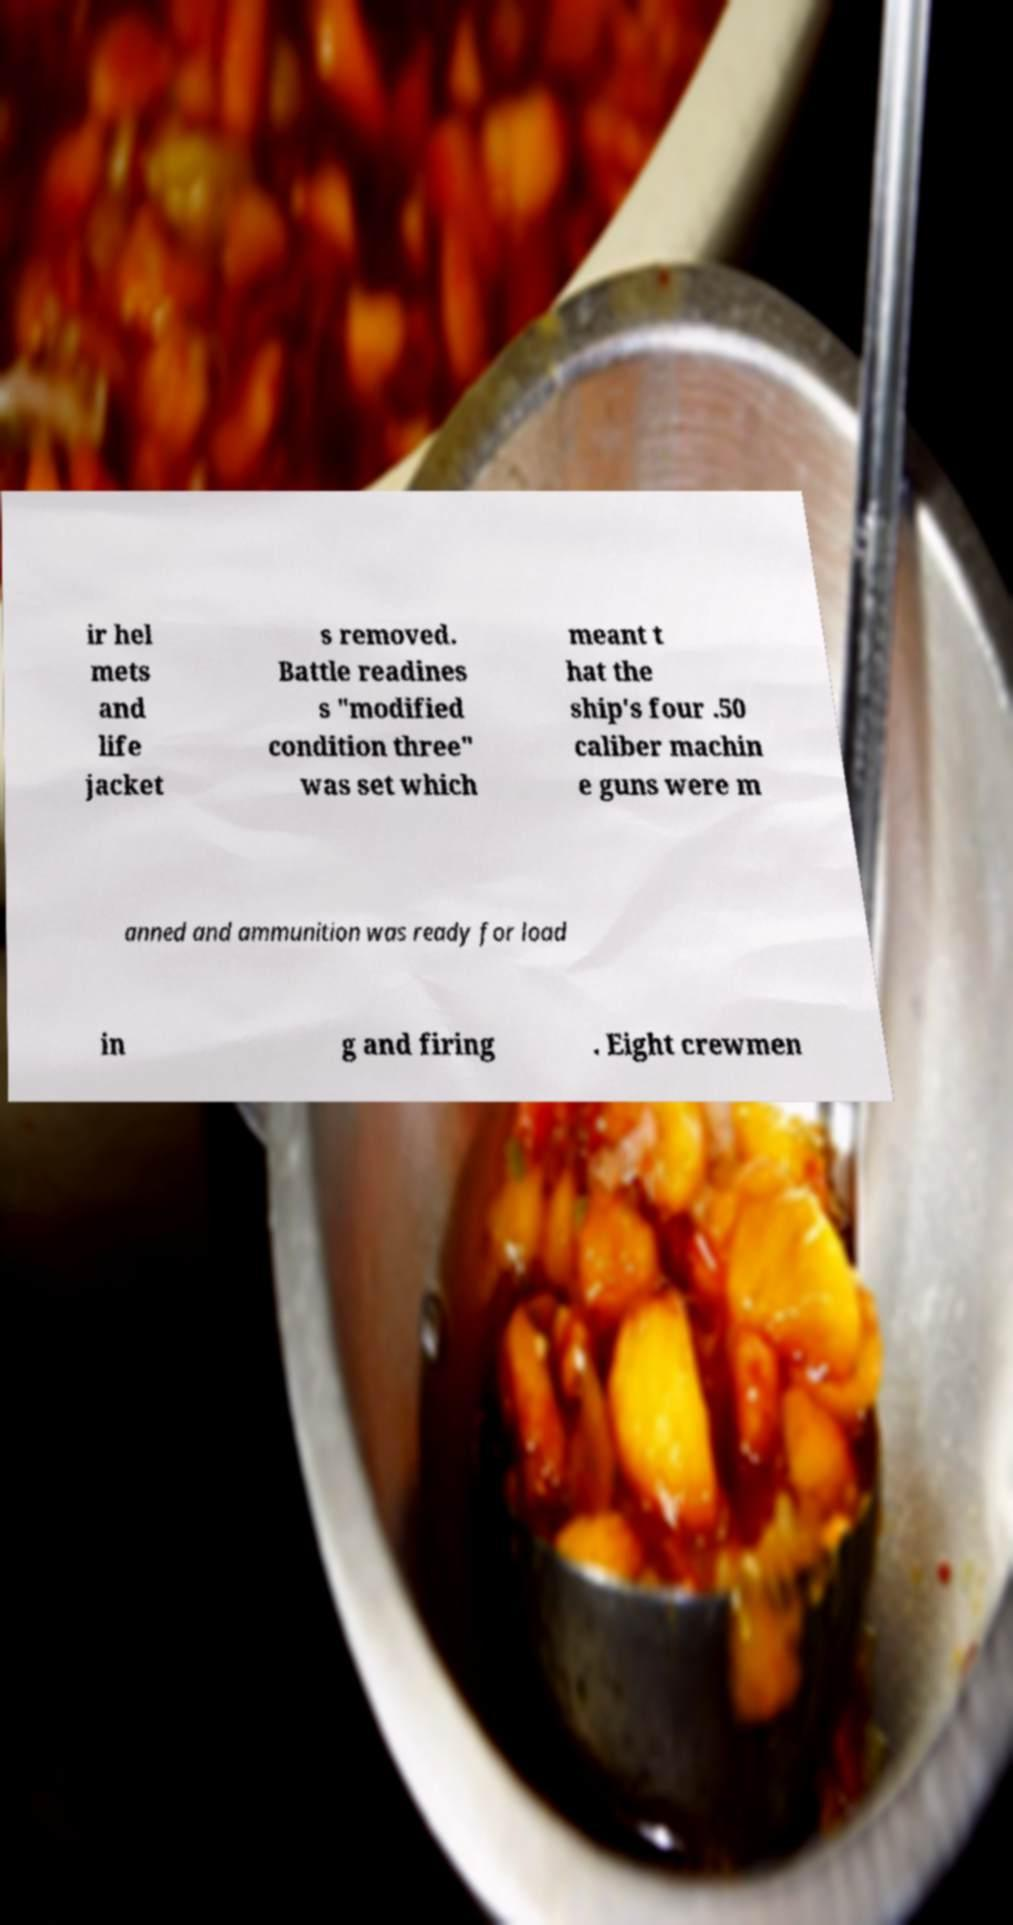Could you assist in decoding the text presented in this image and type it out clearly? ir hel mets and life jacket s removed. Battle readines s "modified condition three" was set which meant t hat the ship's four .50 caliber machin e guns were m anned and ammunition was ready for load in g and firing . Eight crewmen 